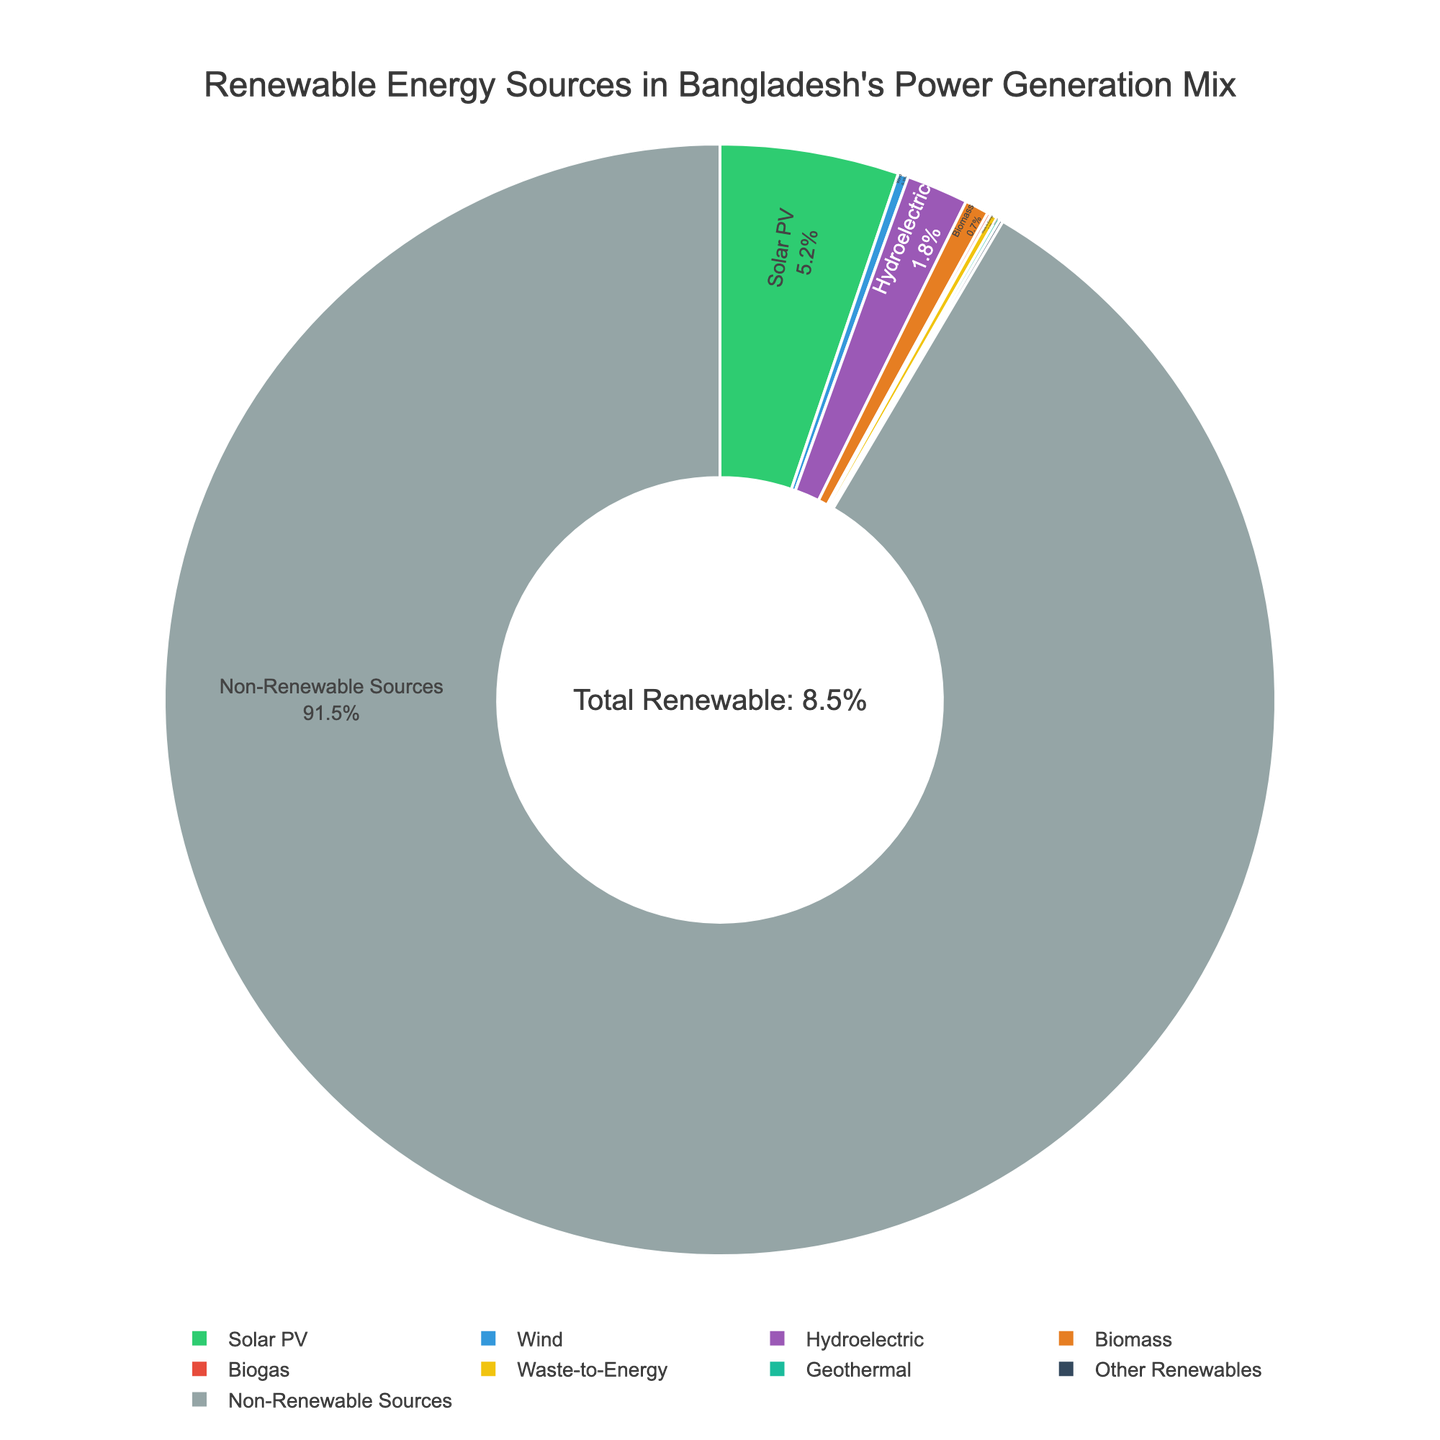What percentage of Bangladesh's power generation mix comes from solar energy? The pie chart shows that the percentage of power generated from solar PV is indicated inside the chart. It is shown as "Solar PV (5.2%)".
Answer: 5.2% Which renewable energy source has the smallest contribution to Bangladesh's power generation mix? The pie chart lists several renewable energy sources along with their percentages. Among them, Biogas, Geothermal, and Other Renewables each contribute 0.1%, and all are the smallest contributions.
Answer: Biogas, Geothermal, Other Renewables How does the contribution of hydroelectric power compare to that of biomass in Bangladesh's renewable energy mix? The pie chart shows that the percentage of power generated from hydroelectric sources is 1.8%, while biomass contributes 0.7%. A simple comparison reveals that hydroelectric power has a higher contribution than biomass.
Answer: Hydroelectric power contribution is higher than biomass What is the combined percentage for solar PV and wind energy? First, look at the individual percentages from the pie chart: Solar PV is 5.2% and Wind is 0.3%. Add these two percentages: 5.2 + 0.3 = 5.5%.
Answer: 5.5% If we exclude non-renewable sources, what percentage of the remaining mix is contributed by solar PV? Excluding non-renewable sources, the total is 100% - 91.5% = 8.5%. The percentage of this remaining mix that comes from Solar PV is calculated as (5.2%/8.5%) * 100.
Answer: 61.18% What is the visual feature used to distinguish Waste-to-Energy on the pie chart? The different segments on the pie chart are distinguished by colors. Waste-to-Energy is represented in a specific color unique to its segment. Look at the segment with the appropriate label on the chart.
Answer: It is distinguished by its unique color Which energy source is represented by the color green in the pie chart? Observing the pie chart, the segment that appears in green color is labeled as Solar PV.
Answer: Solar PV By how much does the percentage contribution of hydroelectric power exceed that of biomass? From the chart, the hydroelectric contribution is 1.8% and biomass is 0.7%. The difference is calculated as 1.8 - 0.7 = 1.1%.
Answer: 1.1% What is the percentage contribution of wind power relative to the total renewable mix? The total renewable mix is 8.5%. Wind power contributes 0.3%. The relative contribution is (0.3/8.5) * 100.
Answer: 3.53% Which two sources combined give a total contribution of 0.3% to the renewable energy mix? From the pie chart, Biogas contributes 0.1% and Geothermal also contributes 0.1%, so we need another source that together with either, adds up to 0.3%. Waste-to-Energy has a contribution of 0.2%, which combines with either Biogas or Geothermal to give a total of 0.3%.
Answer: Biogas and Waste-to-Energy, Geothermal and Waste-to-Energy 